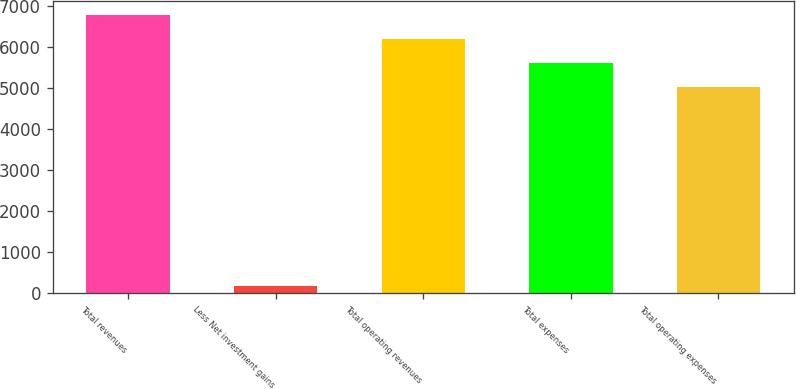Convert chart to OTSL. <chart><loc_0><loc_0><loc_500><loc_500><bar_chart><fcel>Total revenues<fcel>Less Net investment gains<fcel>Total operating revenues<fcel>Total expenses<fcel>Total operating expenses<nl><fcel>6776.6<fcel>169<fcel>6193.4<fcel>5610.2<fcel>5027<nl></chart> 